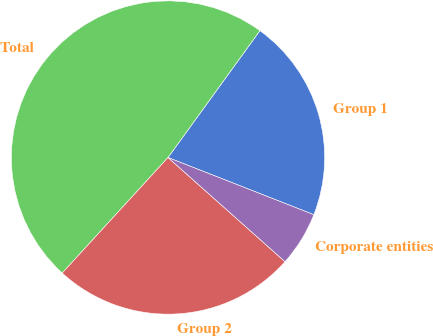Convert chart to OTSL. <chart><loc_0><loc_0><loc_500><loc_500><pie_chart><fcel>Group 1<fcel>Total<fcel>Group 2<fcel>Corporate entities<nl><fcel>20.97%<fcel>48.18%<fcel>25.22%<fcel>5.63%<nl></chart> 